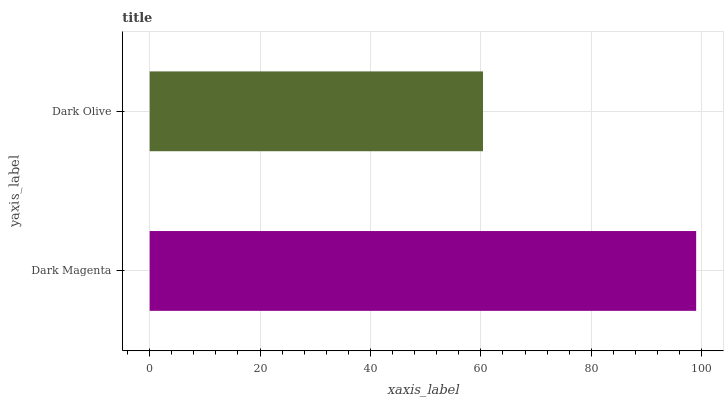Is Dark Olive the minimum?
Answer yes or no. Yes. Is Dark Magenta the maximum?
Answer yes or no. Yes. Is Dark Olive the maximum?
Answer yes or no. No. Is Dark Magenta greater than Dark Olive?
Answer yes or no. Yes. Is Dark Olive less than Dark Magenta?
Answer yes or no. Yes. Is Dark Olive greater than Dark Magenta?
Answer yes or no. No. Is Dark Magenta less than Dark Olive?
Answer yes or no. No. Is Dark Magenta the high median?
Answer yes or no. Yes. Is Dark Olive the low median?
Answer yes or no. Yes. Is Dark Olive the high median?
Answer yes or no. No. Is Dark Magenta the low median?
Answer yes or no. No. 